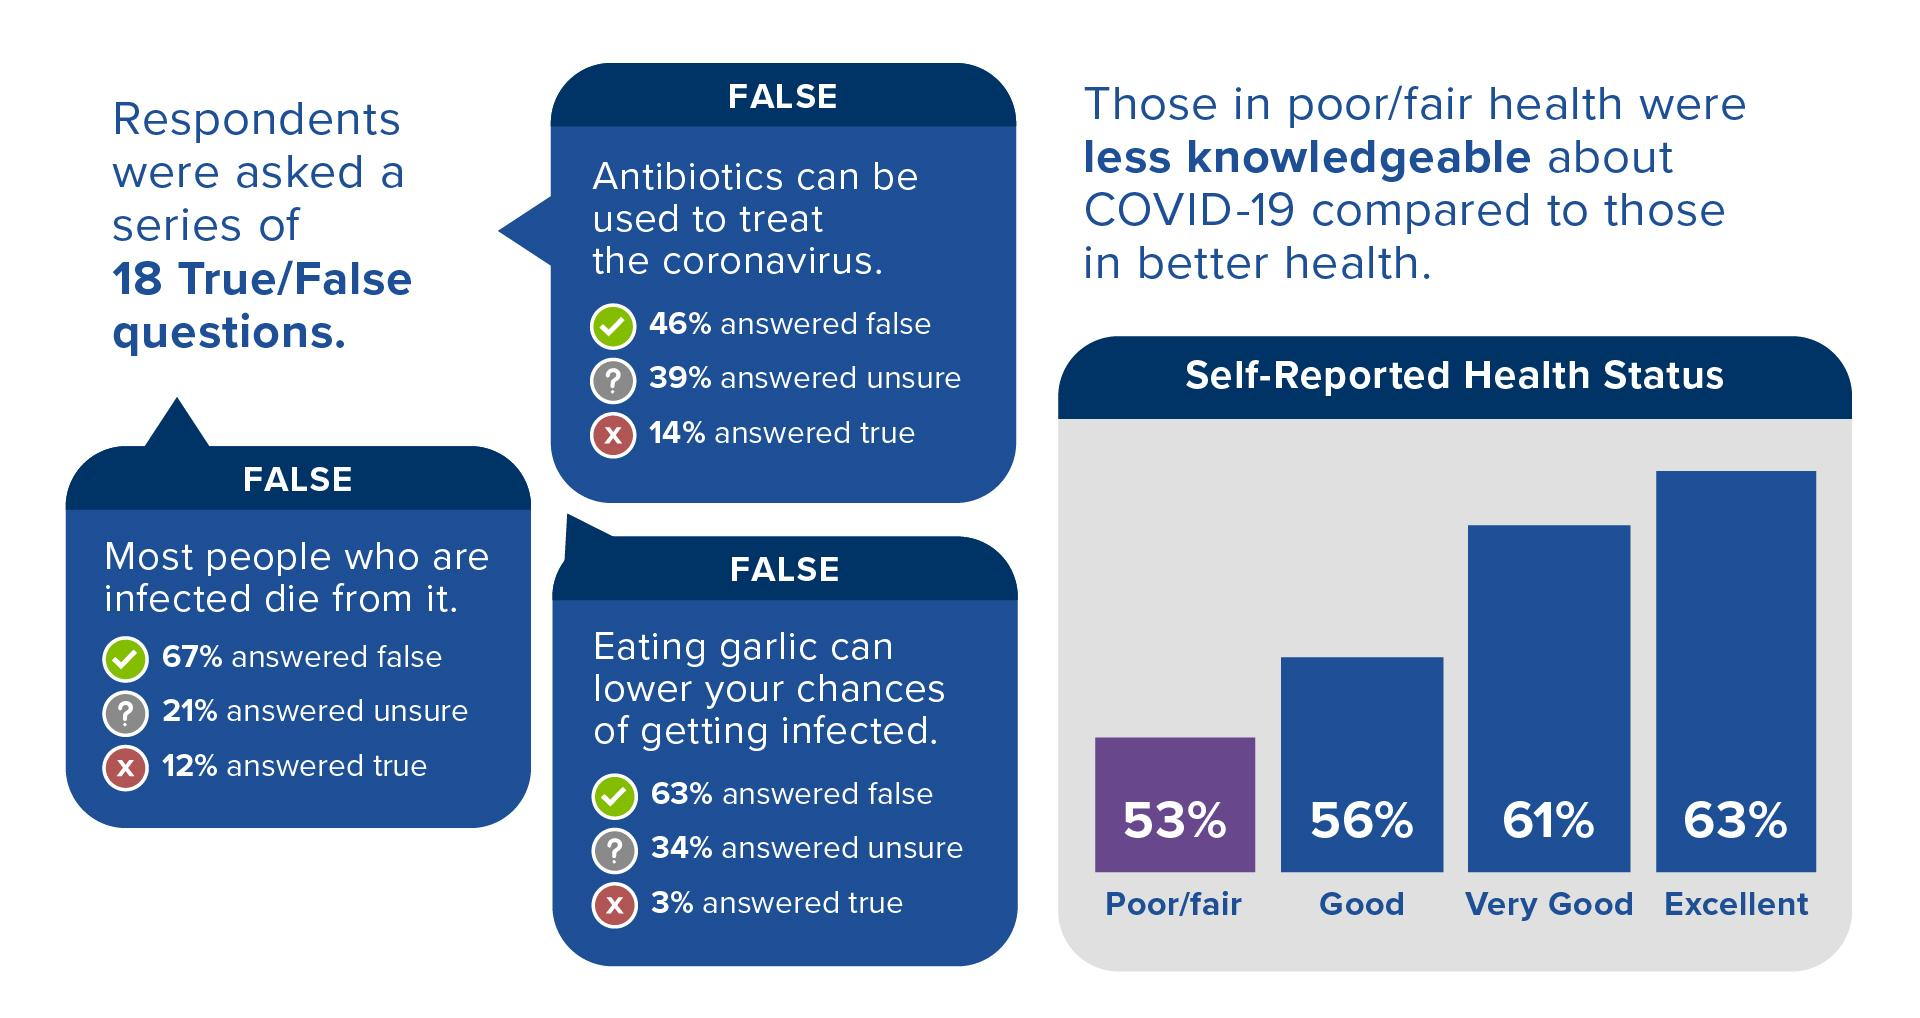Highlight a few significant elements in this photo. Antibiotics are not effective in treating the COVID-19 virus, and the most popular answer for the question on whether antibiotics can be used to treat the coronavirus is false. According to self-reported health status, the second most common response is "very good. According to the survey, most respondents indicated that their health status was excellent. 